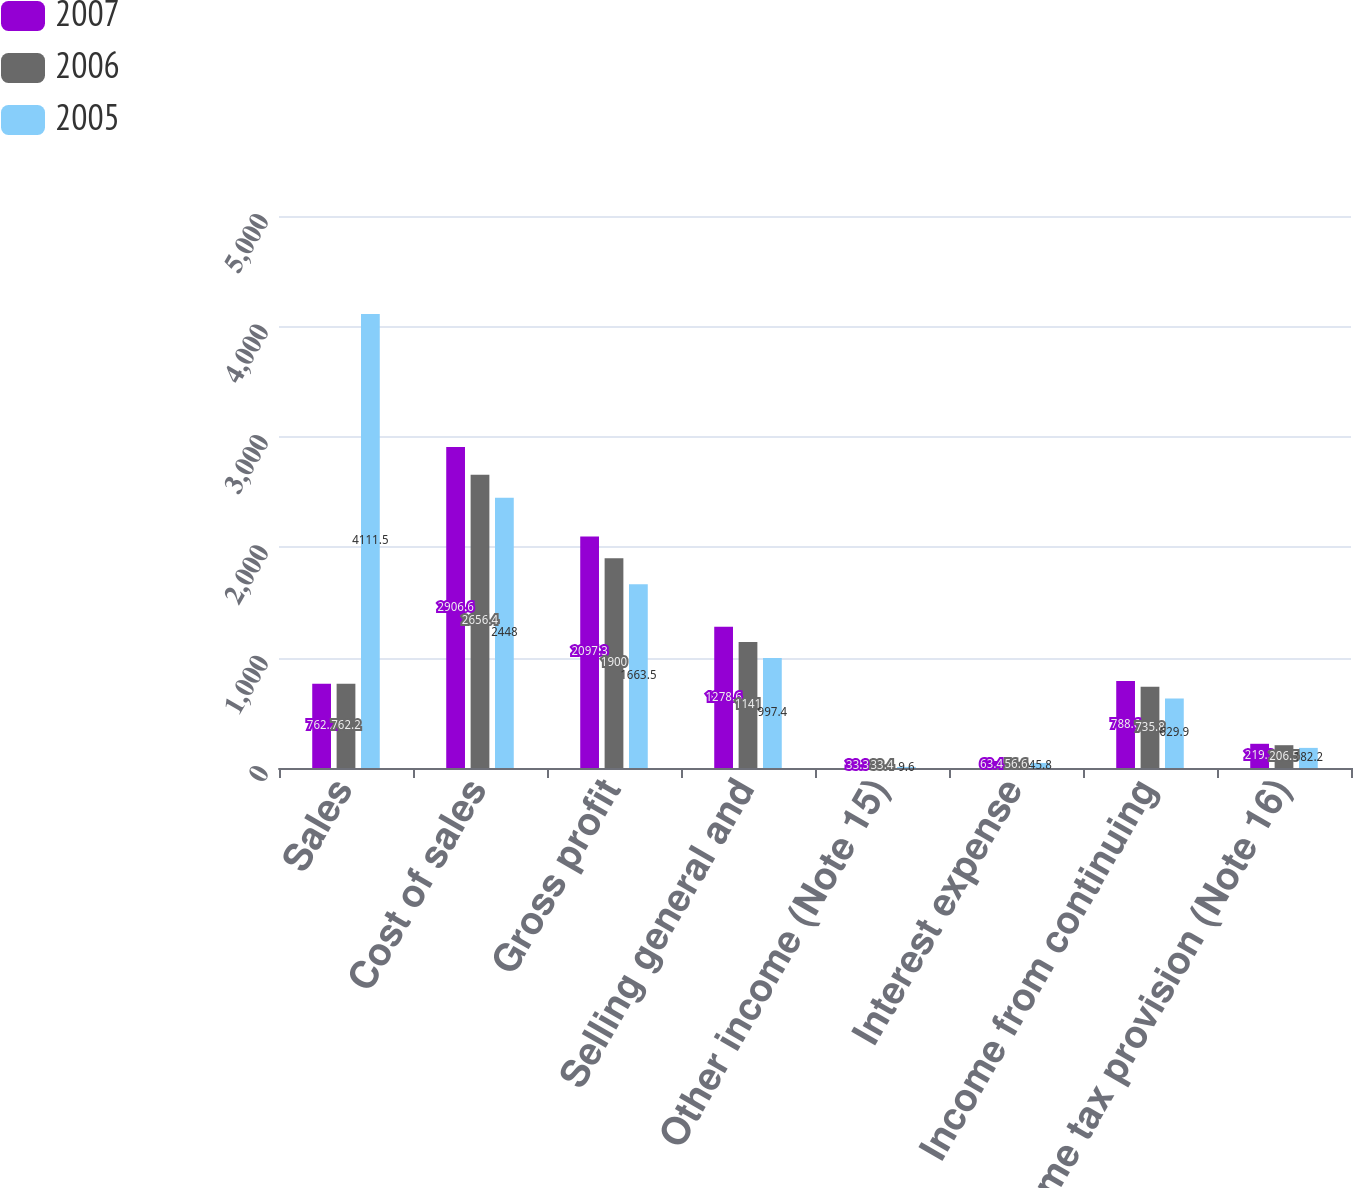Convert chart. <chart><loc_0><loc_0><loc_500><loc_500><stacked_bar_chart><ecel><fcel>Sales<fcel>Cost of sales<fcel>Gross profit<fcel>Selling general and<fcel>Other income (Note 15)<fcel>Interest expense<fcel>Income from continuing<fcel>Income tax provision (Note 16)<nl><fcel>2007<fcel>762.2<fcel>2906.6<fcel>2097.3<fcel>1278.6<fcel>33.3<fcel>63.4<fcel>788.6<fcel>219.3<nl><fcel>2006<fcel>762.2<fcel>2656.4<fcel>1900<fcel>1141<fcel>33.4<fcel>56.6<fcel>735.8<fcel>206.5<nl><fcel>2005<fcel>4111.5<fcel>2448<fcel>1663.5<fcel>997.4<fcel>9.6<fcel>45.8<fcel>629.9<fcel>182.2<nl></chart> 